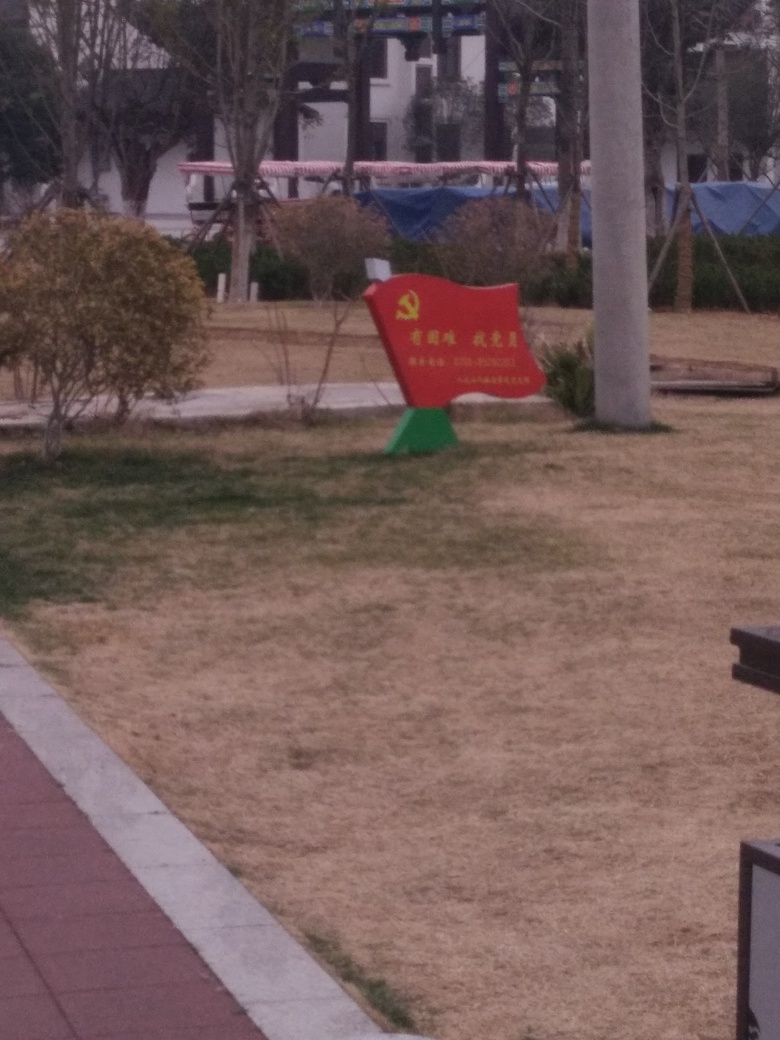Can you infer what type of environment or setting this image is taken in? The setting appears to be a public space, potentially a park, considering the presence of a bench, walkway, trimmed bushes, and open areas commonly associated with community-accessible areas where people can spend leisure time outdoors. Is there anything in this image that might indicate its location, such as country or region? The emblem on the red bench bears an insignia that is reminiscent of the emblem used by the Communist Party, which suggests the image might be taken in a country where such symbolism is significant, possibly China. The vegetation and architecture also could be indicative of this region, although this is more speculative. 